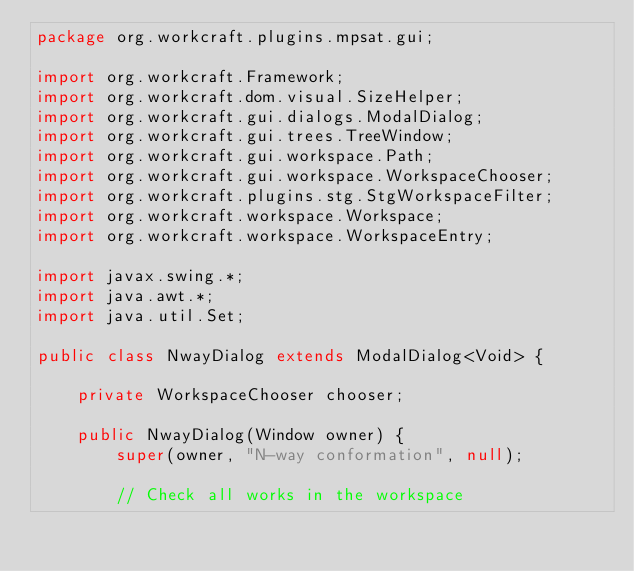<code> <loc_0><loc_0><loc_500><loc_500><_Java_>package org.workcraft.plugins.mpsat.gui;

import org.workcraft.Framework;
import org.workcraft.dom.visual.SizeHelper;
import org.workcraft.gui.dialogs.ModalDialog;
import org.workcraft.gui.trees.TreeWindow;
import org.workcraft.gui.workspace.Path;
import org.workcraft.gui.workspace.WorkspaceChooser;
import org.workcraft.plugins.stg.StgWorkspaceFilter;
import org.workcraft.workspace.Workspace;
import org.workcraft.workspace.WorkspaceEntry;

import javax.swing.*;
import java.awt.*;
import java.util.Set;

public class NwayDialog extends ModalDialog<Void> {

    private WorkspaceChooser chooser;

    public NwayDialog(Window owner) {
        super(owner, "N-way conformation", null);

        // Check all works in the workspace</code> 